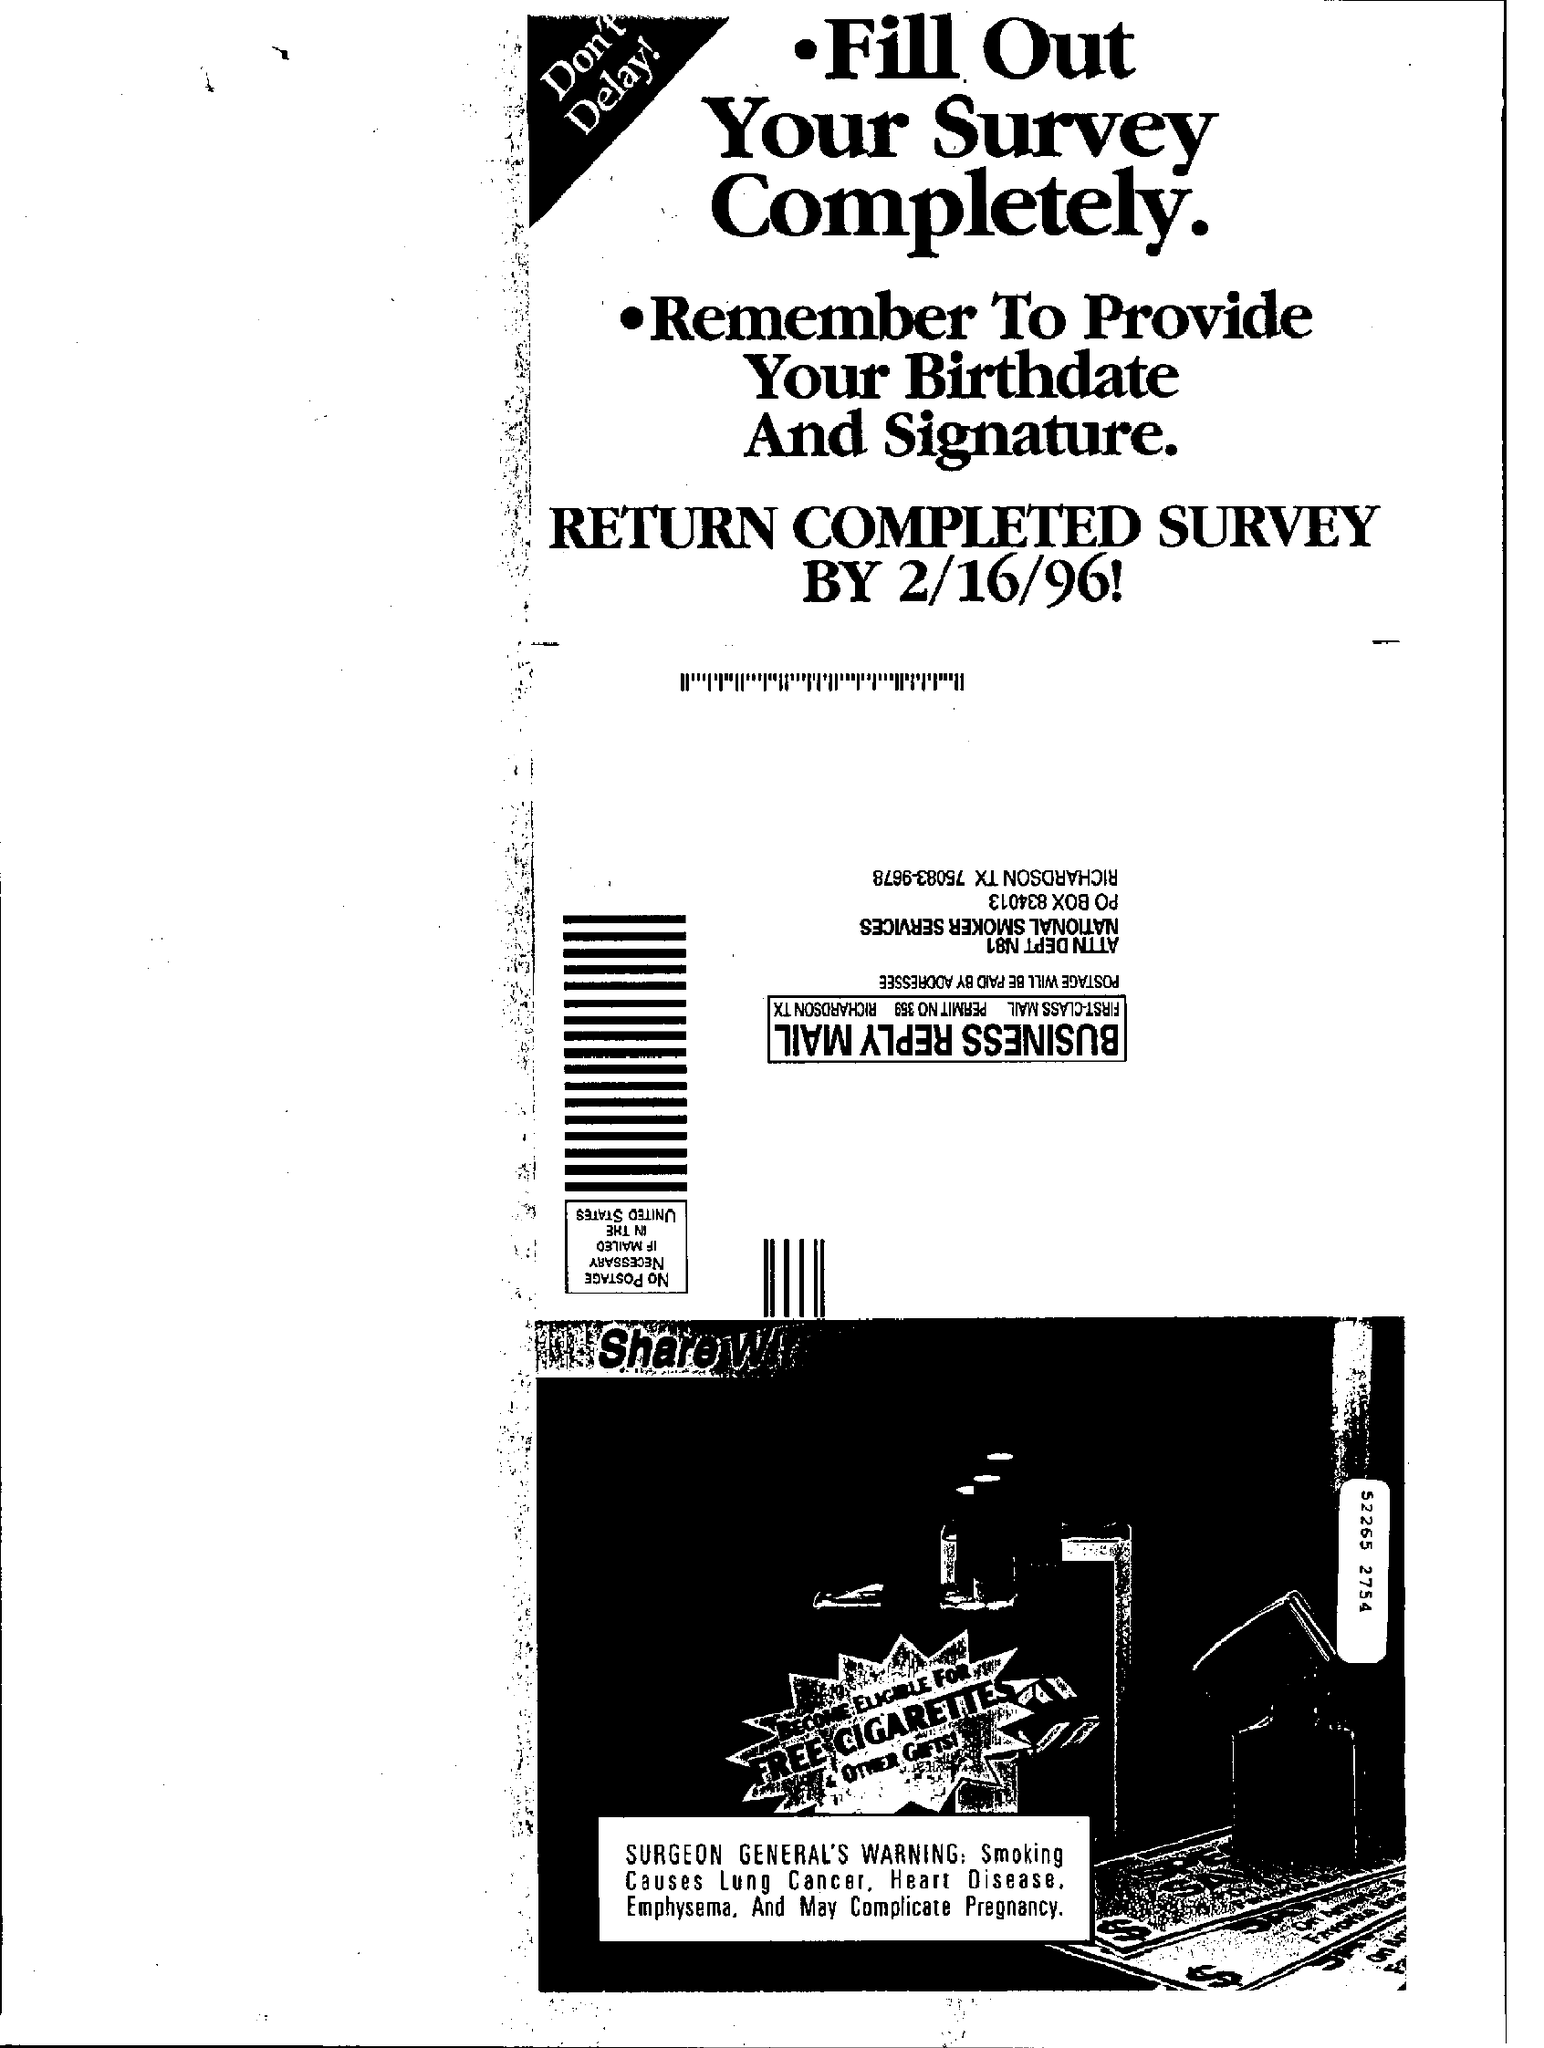Give some essential details in this illustration. The Completed survey should be returned by February 16th, 1996. It is necessary for the application to collect the individual's birthdate and signature for the purposes of verifying identity and complying with legal requirements. 